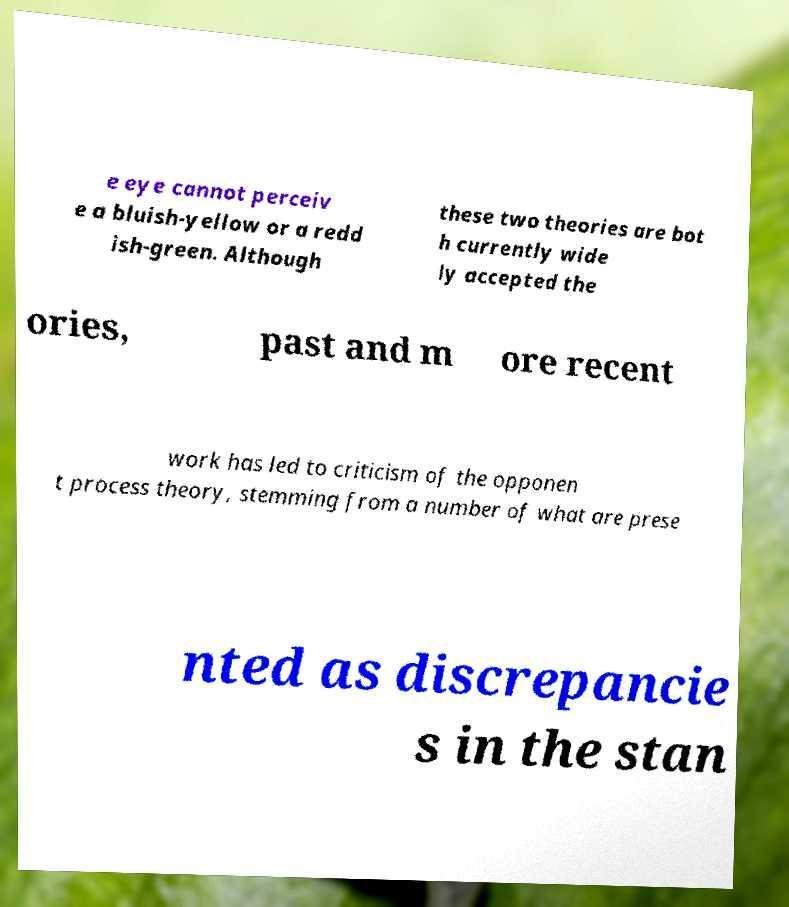I need the written content from this picture converted into text. Can you do that? e eye cannot perceiv e a bluish-yellow or a redd ish-green. Although these two theories are bot h currently wide ly accepted the ories, past and m ore recent work has led to criticism of the opponen t process theory, stemming from a number of what are prese nted as discrepancie s in the stan 